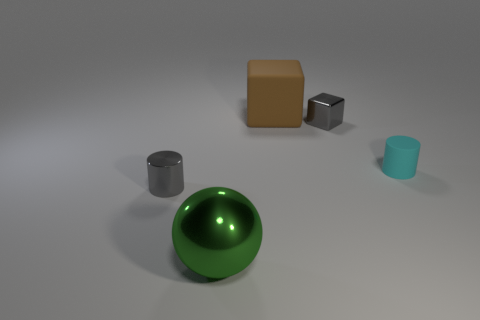Is the number of brown rubber cubes to the left of the gray metal cylinder less than the number of big gray objects?
Provide a short and direct response. No. How many tiny gray blocks are there?
Your response must be concise. 1. There is a thing that is behind the gray object on the right side of the large green metal sphere; what shape is it?
Your answer should be compact. Cube. What number of shiny cylinders are to the right of the shiny block?
Keep it short and to the point. 0. Is the material of the cyan thing the same as the small thing to the left of the gray block?
Give a very brief answer. No. Is there a gray cylinder of the same size as the green metal ball?
Give a very brief answer. No. Is the number of green spheres right of the tiny cyan thing the same as the number of tiny green metal blocks?
Ensure brevity in your answer.  Yes. How big is the cyan object?
Give a very brief answer. Small. What number of big objects are left of the small gray metallic thing left of the brown thing?
Give a very brief answer. 0. What shape is the thing that is behind the tiny matte cylinder and left of the tiny metal block?
Provide a short and direct response. Cube. 